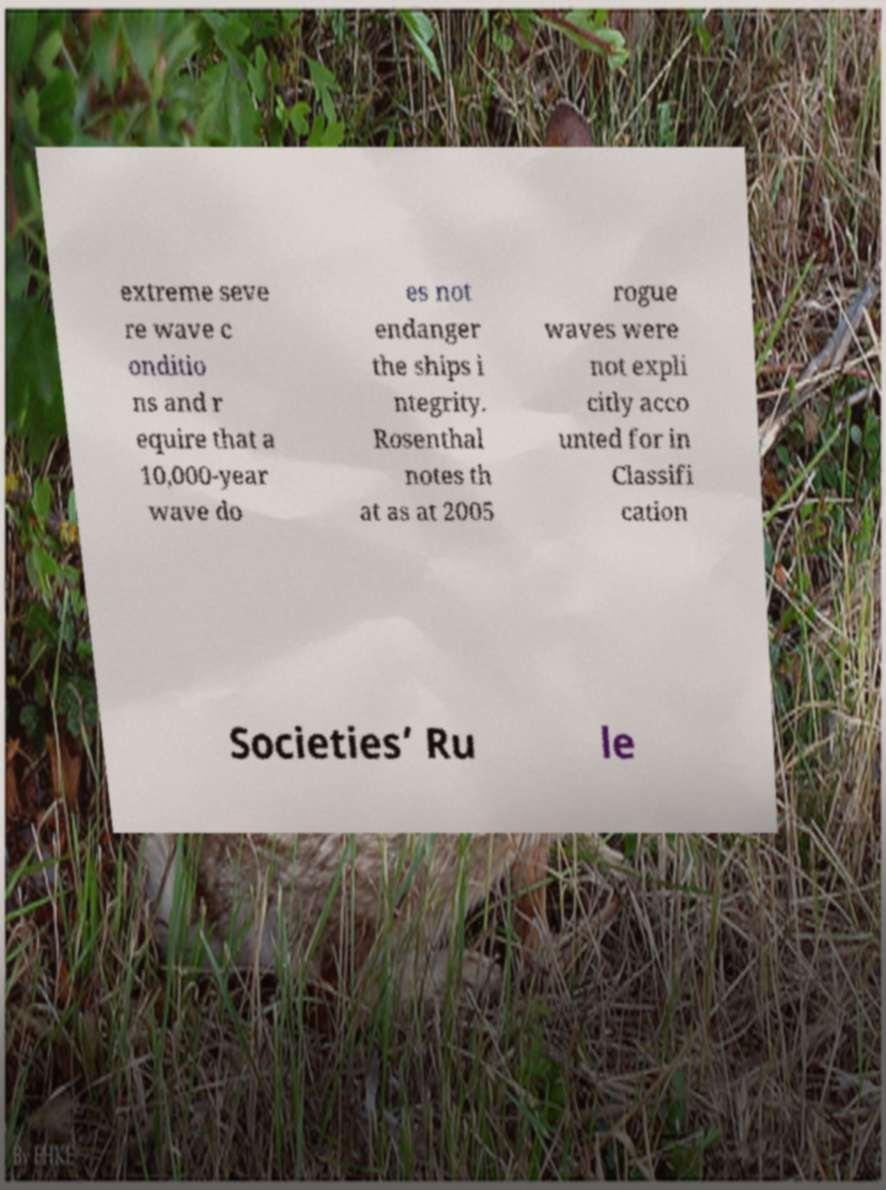Could you assist in decoding the text presented in this image and type it out clearly? extreme seve re wave c onditio ns and r equire that a 10,000-year wave do es not endanger the ships i ntegrity. Rosenthal notes th at as at 2005 rogue waves were not expli citly acco unted for in Classifi cation Societies’ Ru le 